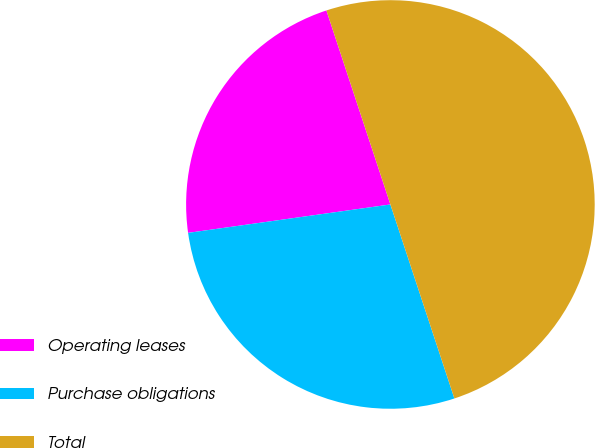Convert chart. <chart><loc_0><loc_0><loc_500><loc_500><pie_chart><fcel>Operating leases<fcel>Purchase obligations<fcel>Total<nl><fcel>22.15%<fcel>27.85%<fcel>50.0%<nl></chart> 